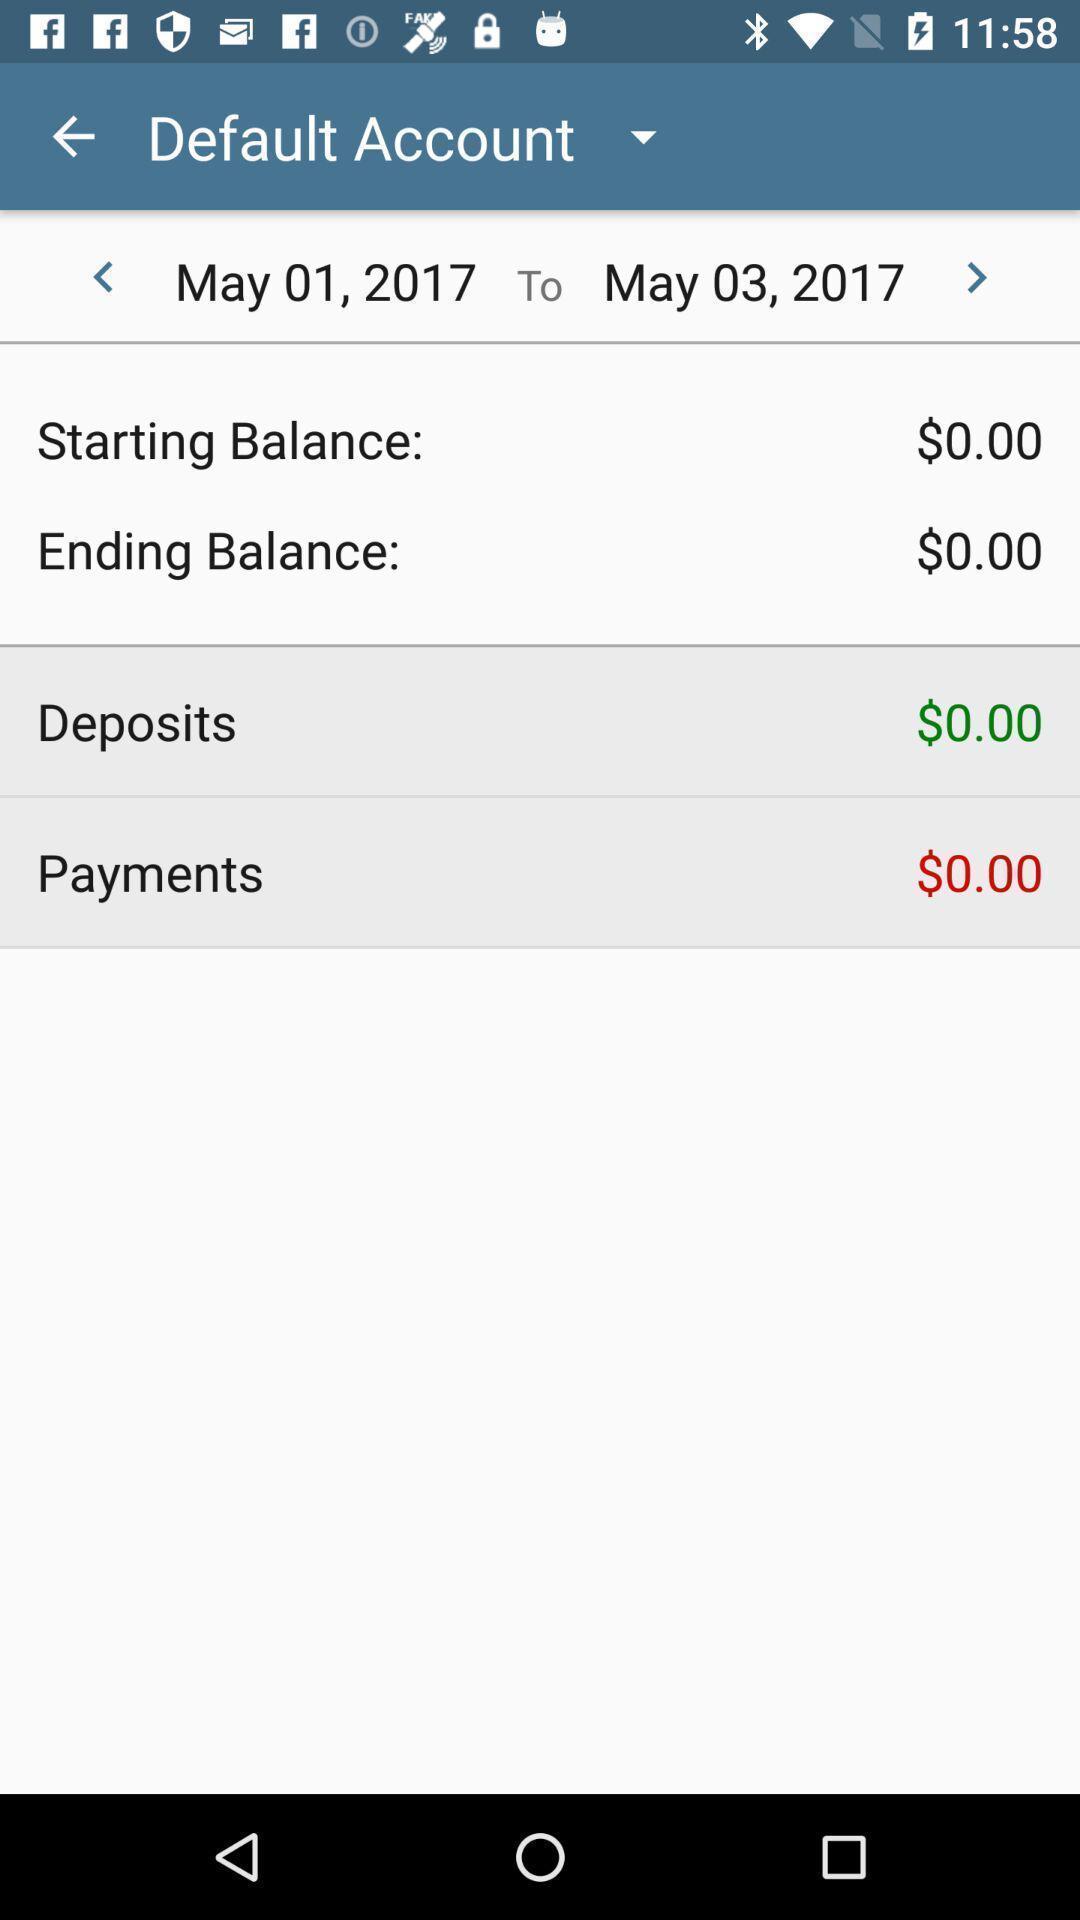Describe the content in this image. Screen shows the track of a bank accounts. 